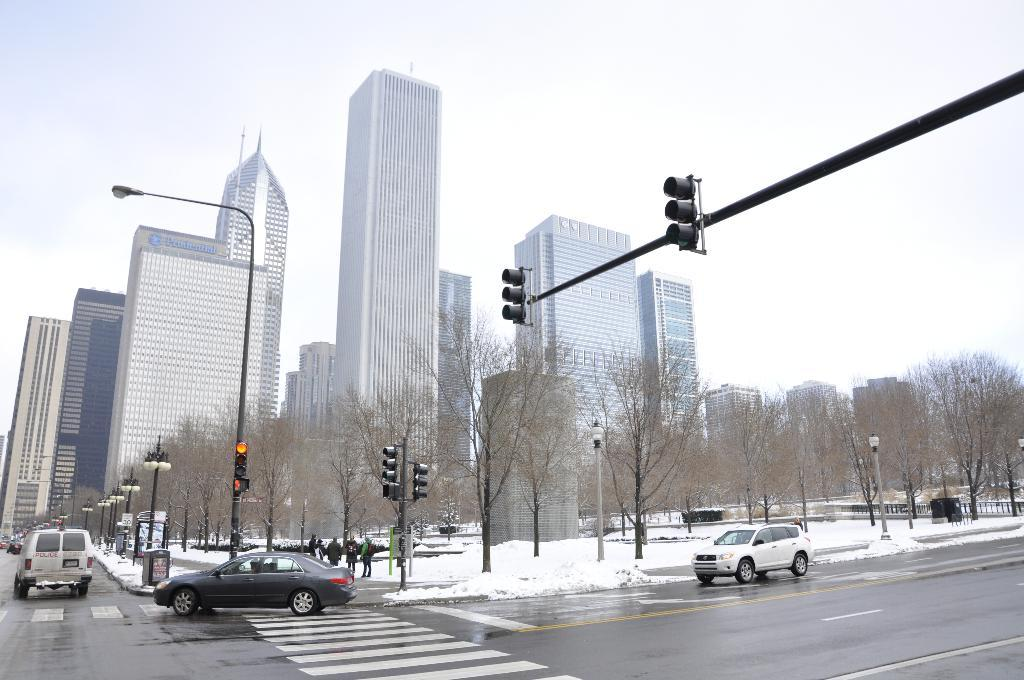What can be seen in the image that moves on roads or streets? There are vehicles in the image. What type of weather condition is depicted in the image? There is snow in the image. What type of natural vegetation is present in the image? There are trees in the image. What type of illumination is present in the image? There are lights in the image. What type of structures can be seen in the background of the image? There are buildings in the background of the image. What is visible at the top of the image? The sky is visible at the top of the image. What type of lumber is being used to construct the buildings in the image? There is no information about the type of lumber used to construct the buildings in the image. How does the ice affect the movement of the vehicles in the image? The image does not depict any ice on the roads or streets, so it cannot be determined how it would affect the movement of the vehicles. 